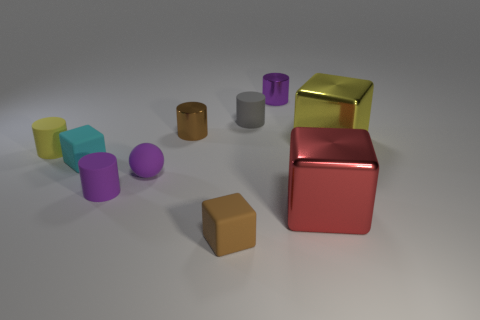There is a tiny object that is on the left side of the small purple sphere and in front of the purple rubber sphere; what shape is it?
Give a very brief answer. Cylinder. The yellow cylinder that is the same material as the sphere is what size?
Your answer should be very brief. Small. There is a tiny ball; does it have the same color as the small shiny cylinder behind the brown cylinder?
Offer a terse response. Yes. What is the cube that is both on the right side of the cyan cube and left of the red metal object made of?
Provide a short and direct response. Rubber. There is a shiny thing that is the same color as the small sphere; what is its size?
Your answer should be compact. Small. There is a tiny matte object that is on the left side of the cyan thing; is its shape the same as the tiny brown thing behind the small cyan cube?
Offer a terse response. Yes. Is there a red matte cube?
Provide a succinct answer. No. What is the color of the other metal thing that is the same shape as the purple metal thing?
Offer a terse response. Brown. What color is the rubber sphere that is the same size as the yellow rubber thing?
Provide a succinct answer. Purple. Do the small yellow thing and the big yellow cube have the same material?
Your answer should be compact. No. 